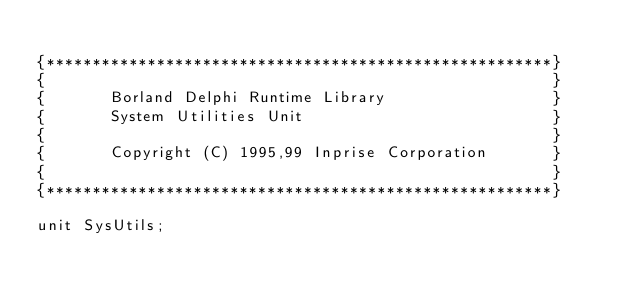Convert code to text. <code><loc_0><loc_0><loc_500><loc_500><_Pascal_>
{*******************************************************}
{                                                       }
{       Borland Delphi Runtime Library                  }
{       System Utilities Unit                           }
{                                                       }
{       Copyright (C) 1995,99 Inprise Corporation       }
{                                                       }
{*******************************************************}

unit SysUtils;
</code> 